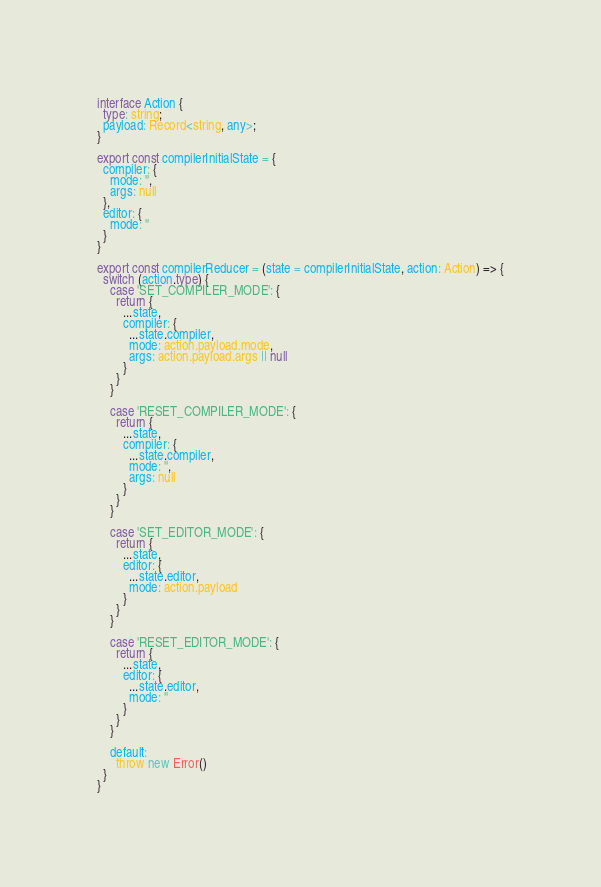<code> <loc_0><loc_0><loc_500><loc_500><_TypeScript_>interface Action {
  type: string;
  payload: Record<string, any>;
}

export const compilerInitialState = {
  compiler: {
    mode: '',
    args: null
  },
  editor: {
    mode: ''
  }
}

export const compilerReducer = (state = compilerInitialState, action: Action) => {
  switch (action.type) {
    case 'SET_COMPILER_MODE': {
      return {
        ...state,
        compiler: {
          ...state.compiler,
          mode: action.payload.mode,
          args: action.payload.args || null
        }
      }
    }

    case 'RESET_COMPILER_MODE': {
      return {
        ...state,
        compiler: {
          ...state.compiler,
          mode: '',
          args: null
        }
      }
    }

    case 'SET_EDITOR_MODE': {
      return {
        ...state,
        editor: {
          ...state.editor,
          mode: action.payload
        }
      }
    }

    case 'RESET_EDITOR_MODE': {
      return {
        ...state,
        editor: {
          ...state.editor,
          mode: ''
        }
      }
    }

    default:
      throw new Error()
  }
}
</code> 